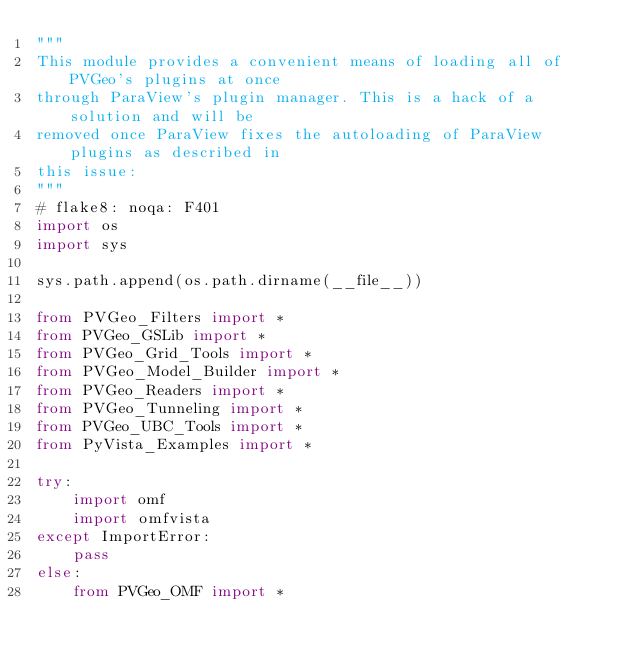<code> <loc_0><loc_0><loc_500><loc_500><_Python_>"""
This module provides a convenient means of loading all of PVGeo's plugins at once
through ParaView's plugin manager. This is a hack of a solution and will be
removed once ParaView fixes the autoloading of ParaView plugins as described in
this issue:
"""
# flake8: noqa: F401
import os
import sys

sys.path.append(os.path.dirname(__file__))

from PVGeo_Filters import *
from PVGeo_GSLib import *
from PVGeo_Grid_Tools import *
from PVGeo_Model_Builder import *
from PVGeo_Readers import *
from PVGeo_Tunneling import *
from PVGeo_UBC_Tools import *
from PyVista_Examples import *

try:
    import omf
    import omfvista
except ImportError:
    pass
else:
    from PVGeo_OMF import *
</code> 